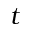<formula> <loc_0><loc_0><loc_500><loc_500>t</formula> 